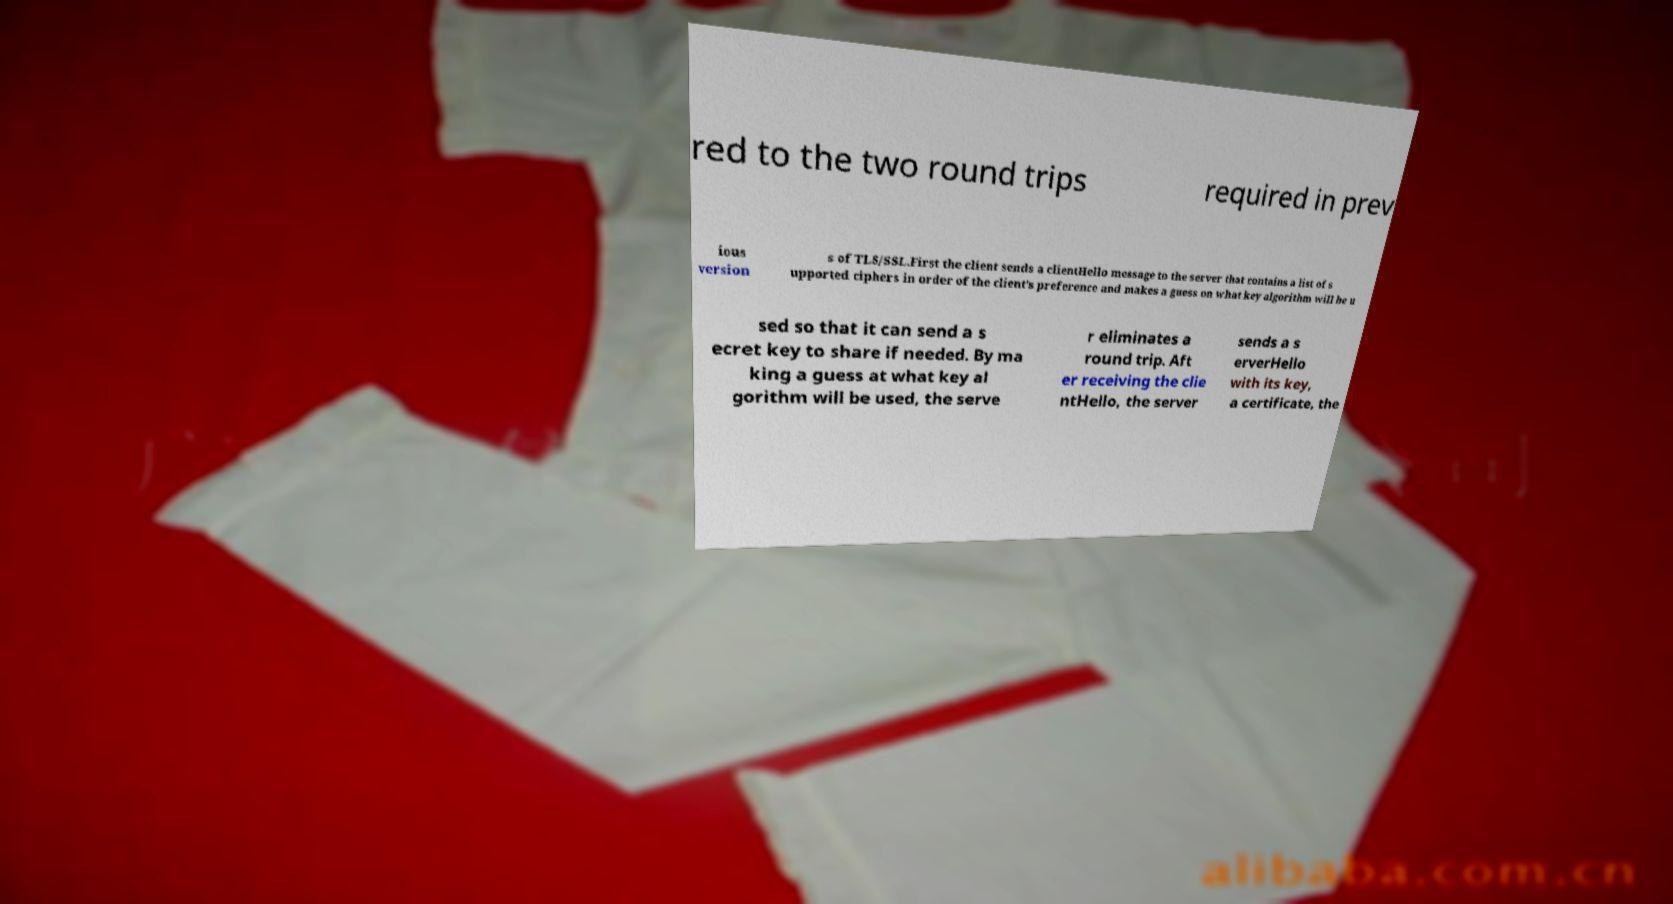I need the written content from this picture converted into text. Can you do that? red to the two round trips required in prev ious version s of TLS/SSL.First the client sends a clientHello message to the server that contains a list of s upported ciphers in order of the client's preference and makes a guess on what key algorithm will be u sed so that it can send a s ecret key to share if needed. By ma king a guess at what key al gorithm will be used, the serve r eliminates a round trip. Aft er receiving the clie ntHello, the server sends a s erverHello with its key, a certificate, the 